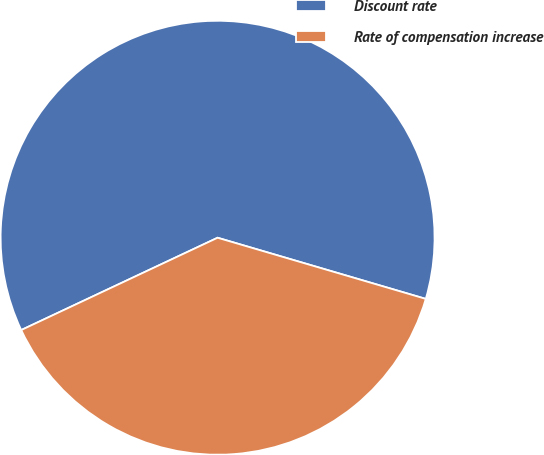Convert chart. <chart><loc_0><loc_0><loc_500><loc_500><pie_chart><fcel>Discount rate<fcel>Rate of compensation increase<nl><fcel>61.54%<fcel>38.46%<nl></chart> 